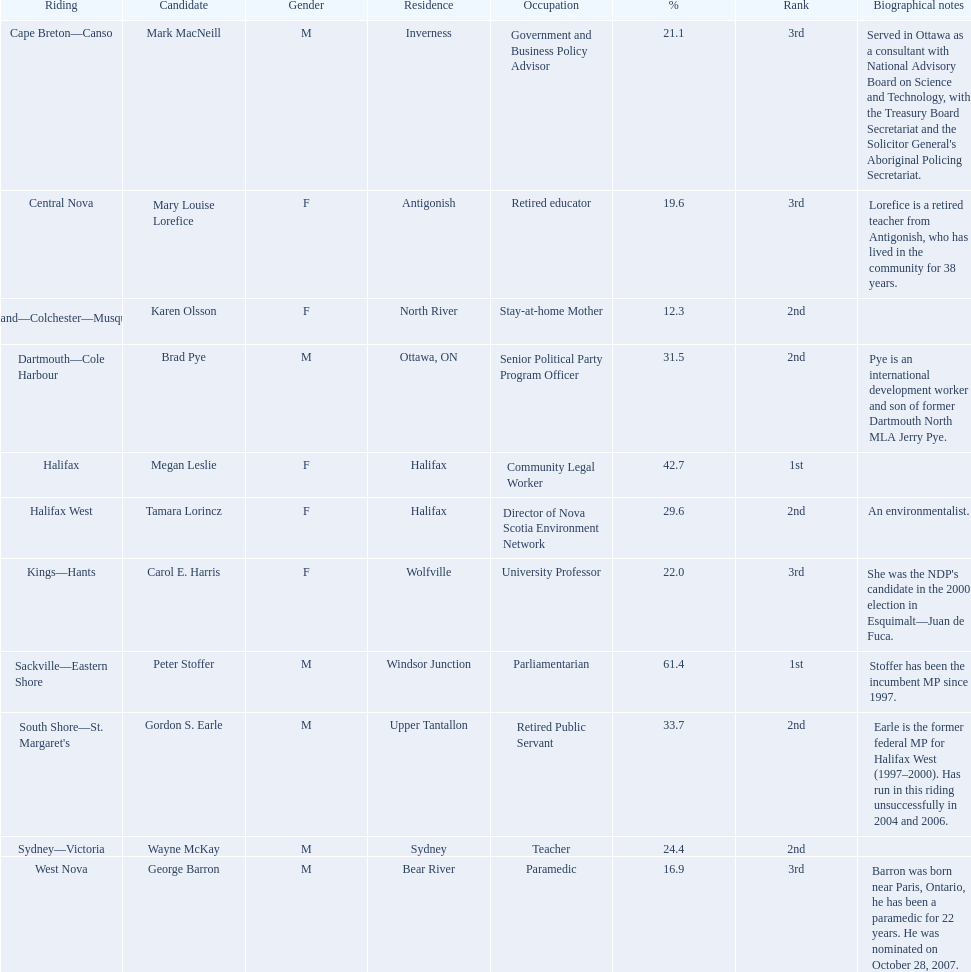Who were the new democratic party candidates, 2008? Mark MacNeill, Mary Louise Lorefice, Karen Olsson, Brad Pye, Megan Leslie, Tamara Lorincz, Carol E. Harris, Peter Stoffer, Gordon S. Earle, Wayne McKay, George Barron. Who had the 2nd highest number of votes? Megan Leslie, Peter Stoffer. How many votes did she receive? 19,252. Help me parse the entirety of this table. {'header': ['Riding', 'Candidate', 'Gender', 'Residence', 'Occupation', '%', 'Rank', 'Biographical notes'], 'rows': [['Cape Breton—Canso', 'Mark MacNeill', 'M', 'Inverness', 'Government and Business Policy Advisor', '21.1', '3rd', "Served in Ottawa as a consultant with National Advisory Board on Science and Technology, with the Treasury Board Secretariat and the Solicitor General's Aboriginal Policing Secretariat."], ['Central Nova', 'Mary Louise Lorefice', 'F', 'Antigonish', 'Retired educator', '19.6', '3rd', 'Lorefice is a retired teacher from Antigonish, who has lived in the community for 38 years.'], ['Cumberland—Colchester—Musquodoboit Valley', 'Karen Olsson', 'F', 'North River', 'Stay-at-home Mother', '12.3', '2nd', ''], ['Dartmouth—Cole Harbour', 'Brad Pye', 'M', 'Ottawa, ON', 'Senior Political Party Program Officer', '31.5', '2nd', 'Pye is an international development worker and son of former Dartmouth North MLA Jerry Pye.'], ['Halifax', 'Megan Leslie', 'F', 'Halifax', 'Community Legal Worker', '42.7', '1st', ''], ['Halifax West', 'Tamara Lorincz', 'F', 'Halifax', 'Director of Nova Scotia Environment Network', '29.6', '2nd', 'An environmentalist.'], ['Kings—Hants', 'Carol E. Harris', 'F', 'Wolfville', 'University Professor', '22.0', '3rd', "She was the NDP's candidate in the 2000 election in Esquimalt—Juan de Fuca."], ['Sackville—Eastern Shore', 'Peter Stoffer', 'M', 'Windsor Junction', 'Parliamentarian', '61.4', '1st', 'Stoffer has been the incumbent MP since 1997.'], ["South Shore—St. Margaret's", 'Gordon S. Earle', 'M', 'Upper Tantallon', 'Retired Public Servant', '33.7', '2nd', 'Earle is the former federal MP for Halifax West (1997–2000). Has run in this riding unsuccessfully in 2004 and 2006.'], ['Sydney—Victoria', 'Wayne McKay', 'M', 'Sydney', 'Teacher', '24.4', '2nd', ''], ['West Nova', 'George Barron', 'M', 'Bear River', 'Paramedic', '16.9', '3rd', 'Barron was born near Paris, Ontario, he has been a paramedic for 22 years. He was nominated on October 28, 2007.']]} 